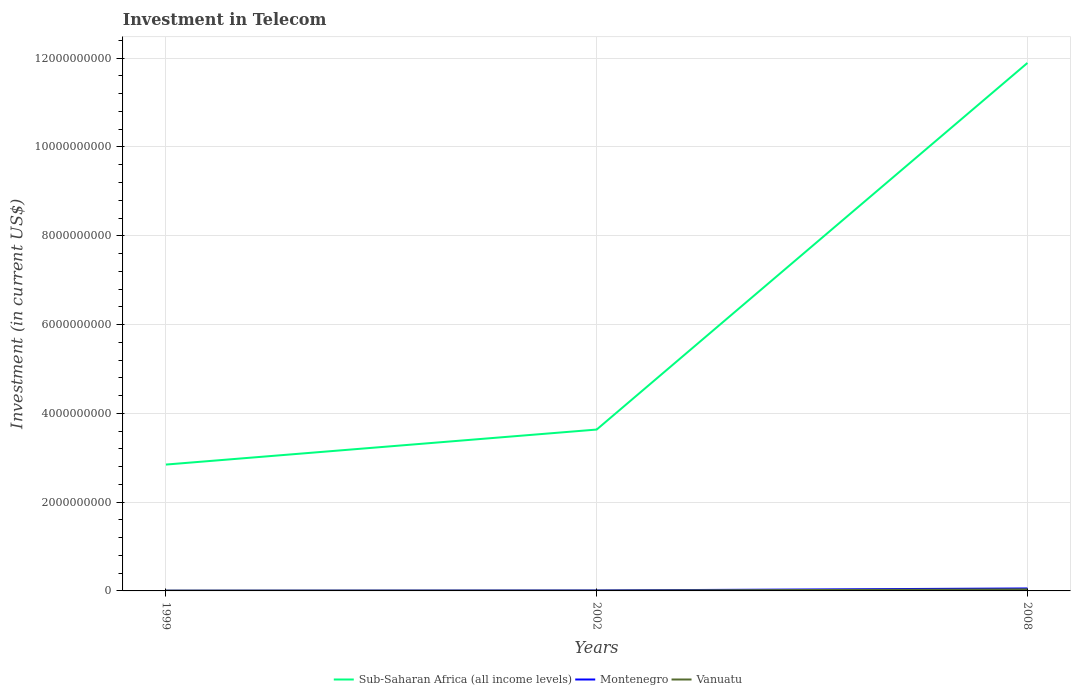How many different coloured lines are there?
Make the answer very short. 3. Does the line corresponding to Sub-Saharan Africa (all income levels) intersect with the line corresponding to Vanuatu?
Ensure brevity in your answer.  No. Is the number of lines equal to the number of legend labels?
Your answer should be very brief. Yes. Across all years, what is the maximum amount invested in telecom in Vanuatu?
Ensure brevity in your answer.  6.00e+06. In which year was the amount invested in telecom in Vanuatu maximum?
Keep it short and to the point. 1999. What is the total amount invested in telecom in Sub-Saharan Africa (all income levels) in the graph?
Provide a short and direct response. -7.89e+08. What is the difference between the highest and the second highest amount invested in telecom in Sub-Saharan Africa (all income levels)?
Provide a succinct answer. 9.05e+09. Is the amount invested in telecom in Montenegro strictly greater than the amount invested in telecom in Vanuatu over the years?
Keep it short and to the point. No. How many lines are there?
Your answer should be very brief. 3. How many years are there in the graph?
Offer a terse response. 3. Are the values on the major ticks of Y-axis written in scientific E-notation?
Offer a terse response. No. Does the graph contain any zero values?
Your response must be concise. No. Does the graph contain grids?
Offer a terse response. Yes. Where does the legend appear in the graph?
Provide a short and direct response. Bottom center. What is the title of the graph?
Make the answer very short. Investment in Telecom. Does "Eritrea" appear as one of the legend labels in the graph?
Your answer should be compact. No. What is the label or title of the X-axis?
Your answer should be compact. Years. What is the label or title of the Y-axis?
Offer a very short reply. Investment (in current US$). What is the Investment (in current US$) in Sub-Saharan Africa (all income levels) in 1999?
Your answer should be compact. 2.85e+09. What is the Investment (in current US$) in Montenegro in 1999?
Give a very brief answer. 5.00e+06. What is the Investment (in current US$) of Vanuatu in 1999?
Ensure brevity in your answer.  6.00e+06. What is the Investment (in current US$) in Sub-Saharan Africa (all income levels) in 2002?
Ensure brevity in your answer.  3.63e+09. What is the Investment (in current US$) of Montenegro in 2002?
Your answer should be compact. 1.01e+07. What is the Investment (in current US$) of Vanuatu in 2002?
Your response must be concise. 6.00e+06. What is the Investment (in current US$) of Sub-Saharan Africa (all income levels) in 2008?
Your answer should be compact. 1.19e+1. What is the Investment (in current US$) of Montenegro in 2008?
Ensure brevity in your answer.  5.55e+07. What is the Investment (in current US$) in Vanuatu in 2008?
Offer a terse response. 3.50e+07. Across all years, what is the maximum Investment (in current US$) of Sub-Saharan Africa (all income levels)?
Provide a succinct answer. 1.19e+1. Across all years, what is the maximum Investment (in current US$) in Montenegro?
Ensure brevity in your answer.  5.55e+07. Across all years, what is the maximum Investment (in current US$) of Vanuatu?
Make the answer very short. 3.50e+07. Across all years, what is the minimum Investment (in current US$) in Sub-Saharan Africa (all income levels)?
Keep it short and to the point. 2.85e+09. Across all years, what is the minimum Investment (in current US$) in Montenegro?
Your answer should be compact. 5.00e+06. Across all years, what is the minimum Investment (in current US$) in Vanuatu?
Ensure brevity in your answer.  6.00e+06. What is the total Investment (in current US$) in Sub-Saharan Africa (all income levels) in the graph?
Offer a terse response. 1.84e+1. What is the total Investment (in current US$) of Montenegro in the graph?
Offer a terse response. 7.06e+07. What is the total Investment (in current US$) of Vanuatu in the graph?
Provide a succinct answer. 4.70e+07. What is the difference between the Investment (in current US$) in Sub-Saharan Africa (all income levels) in 1999 and that in 2002?
Give a very brief answer. -7.89e+08. What is the difference between the Investment (in current US$) in Montenegro in 1999 and that in 2002?
Your answer should be very brief. -5.10e+06. What is the difference between the Investment (in current US$) in Vanuatu in 1999 and that in 2002?
Offer a terse response. 0. What is the difference between the Investment (in current US$) in Sub-Saharan Africa (all income levels) in 1999 and that in 2008?
Your answer should be compact. -9.05e+09. What is the difference between the Investment (in current US$) of Montenegro in 1999 and that in 2008?
Ensure brevity in your answer.  -5.05e+07. What is the difference between the Investment (in current US$) of Vanuatu in 1999 and that in 2008?
Make the answer very short. -2.90e+07. What is the difference between the Investment (in current US$) of Sub-Saharan Africa (all income levels) in 2002 and that in 2008?
Ensure brevity in your answer.  -8.26e+09. What is the difference between the Investment (in current US$) of Montenegro in 2002 and that in 2008?
Make the answer very short. -4.54e+07. What is the difference between the Investment (in current US$) of Vanuatu in 2002 and that in 2008?
Make the answer very short. -2.90e+07. What is the difference between the Investment (in current US$) in Sub-Saharan Africa (all income levels) in 1999 and the Investment (in current US$) in Montenegro in 2002?
Ensure brevity in your answer.  2.84e+09. What is the difference between the Investment (in current US$) in Sub-Saharan Africa (all income levels) in 1999 and the Investment (in current US$) in Vanuatu in 2002?
Offer a very short reply. 2.84e+09. What is the difference between the Investment (in current US$) in Montenegro in 1999 and the Investment (in current US$) in Vanuatu in 2002?
Give a very brief answer. -1.00e+06. What is the difference between the Investment (in current US$) of Sub-Saharan Africa (all income levels) in 1999 and the Investment (in current US$) of Montenegro in 2008?
Keep it short and to the point. 2.79e+09. What is the difference between the Investment (in current US$) in Sub-Saharan Africa (all income levels) in 1999 and the Investment (in current US$) in Vanuatu in 2008?
Offer a terse response. 2.81e+09. What is the difference between the Investment (in current US$) in Montenegro in 1999 and the Investment (in current US$) in Vanuatu in 2008?
Your response must be concise. -3.00e+07. What is the difference between the Investment (in current US$) of Sub-Saharan Africa (all income levels) in 2002 and the Investment (in current US$) of Montenegro in 2008?
Offer a very short reply. 3.58e+09. What is the difference between the Investment (in current US$) in Sub-Saharan Africa (all income levels) in 2002 and the Investment (in current US$) in Vanuatu in 2008?
Your answer should be compact. 3.60e+09. What is the difference between the Investment (in current US$) of Montenegro in 2002 and the Investment (in current US$) of Vanuatu in 2008?
Provide a succinct answer. -2.49e+07. What is the average Investment (in current US$) in Sub-Saharan Africa (all income levels) per year?
Give a very brief answer. 6.12e+09. What is the average Investment (in current US$) in Montenegro per year?
Give a very brief answer. 2.35e+07. What is the average Investment (in current US$) of Vanuatu per year?
Offer a terse response. 1.57e+07. In the year 1999, what is the difference between the Investment (in current US$) in Sub-Saharan Africa (all income levels) and Investment (in current US$) in Montenegro?
Offer a terse response. 2.84e+09. In the year 1999, what is the difference between the Investment (in current US$) of Sub-Saharan Africa (all income levels) and Investment (in current US$) of Vanuatu?
Provide a succinct answer. 2.84e+09. In the year 2002, what is the difference between the Investment (in current US$) of Sub-Saharan Africa (all income levels) and Investment (in current US$) of Montenegro?
Your answer should be very brief. 3.62e+09. In the year 2002, what is the difference between the Investment (in current US$) in Sub-Saharan Africa (all income levels) and Investment (in current US$) in Vanuatu?
Ensure brevity in your answer.  3.63e+09. In the year 2002, what is the difference between the Investment (in current US$) of Montenegro and Investment (in current US$) of Vanuatu?
Your response must be concise. 4.10e+06. In the year 2008, what is the difference between the Investment (in current US$) of Sub-Saharan Africa (all income levels) and Investment (in current US$) of Montenegro?
Make the answer very short. 1.18e+1. In the year 2008, what is the difference between the Investment (in current US$) in Sub-Saharan Africa (all income levels) and Investment (in current US$) in Vanuatu?
Ensure brevity in your answer.  1.19e+1. In the year 2008, what is the difference between the Investment (in current US$) of Montenegro and Investment (in current US$) of Vanuatu?
Ensure brevity in your answer.  2.05e+07. What is the ratio of the Investment (in current US$) in Sub-Saharan Africa (all income levels) in 1999 to that in 2002?
Provide a short and direct response. 0.78. What is the ratio of the Investment (in current US$) of Montenegro in 1999 to that in 2002?
Offer a very short reply. 0.49. What is the ratio of the Investment (in current US$) of Vanuatu in 1999 to that in 2002?
Offer a terse response. 1. What is the ratio of the Investment (in current US$) of Sub-Saharan Africa (all income levels) in 1999 to that in 2008?
Offer a very short reply. 0.24. What is the ratio of the Investment (in current US$) in Montenegro in 1999 to that in 2008?
Ensure brevity in your answer.  0.09. What is the ratio of the Investment (in current US$) in Vanuatu in 1999 to that in 2008?
Make the answer very short. 0.17. What is the ratio of the Investment (in current US$) of Sub-Saharan Africa (all income levels) in 2002 to that in 2008?
Your response must be concise. 0.31. What is the ratio of the Investment (in current US$) in Montenegro in 2002 to that in 2008?
Provide a short and direct response. 0.18. What is the ratio of the Investment (in current US$) in Vanuatu in 2002 to that in 2008?
Ensure brevity in your answer.  0.17. What is the difference between the highest and the second highest Investment (in current US$) of Sub-Saharan Africa (all income levels)?
Your answer should be very brief. 8.26e+09. What is the difference between the highest and the second highest Investment (in current US$) in Montenegro?
Provide a succinct answer. 4.54e+07. What is the difference between the highest and the second highest Investment (in current US$) in Vanuatu?
Your answer should be compact. 2.90e+07. What is the difference between the highest and the lowest Investment (in current US$) in Sub-Saharan Africa (all income levels)?
Offer a terse response. 9.05e+09. What is the difference between the highest and the lowest Investment (in current US$) of Montenegro?
Offer a very short reply. 5.05e+07. What is the difference between the highest and the lowest Investment (in current US$) of Vanuatu?
Provide a succinct answer. 2.90e+07. 